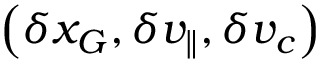Convert formula to latex. <formula><loc_0><loc_0><loc_500><loc_500>\left ( \delta x _ { G } , \delta v _ { \| } , \delta v _ { c } \right )</formula> 